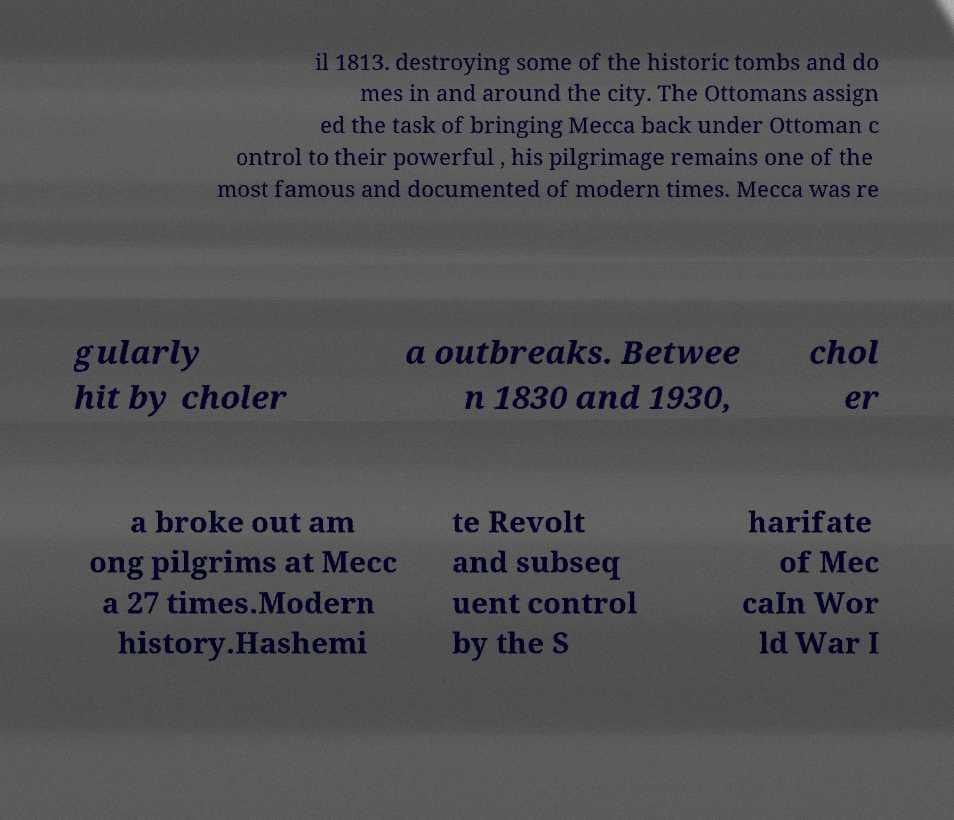Please identify and transcribe the text found in this image. il 1813. destroying some of the historic tombs and do mes in and around the city. The Ottomans assign ed the task of bringing Mecca back under Ottoman c ontrol to their powerful , his pilgrimage remains one of the most famous and documented of modern times. Mecca was re gularly hit by choler a outbreaks. Betwee n 1830 and 1930, chol er a broke out am ong pilgrims at Mecc a 27 times.Modern history.Hashemi te Revolt and subseq uent control by the S harifate of Mec caIn Wor ld War I 